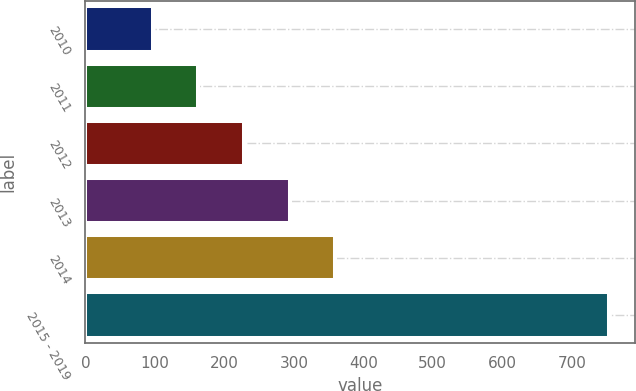Convert chart. <chart><loc_0><loc_0><loc_500><loc_500><bar_chart><fcel>2010<fcel>2011<fcel>2012<fcel>2013<fcel>2014<fcel>2015 - 2019<nl><fcel>97<fcel>162.6<fcel>228.2<fcel>293.8<fcel>359.4<fcel>753<nl></chart> 